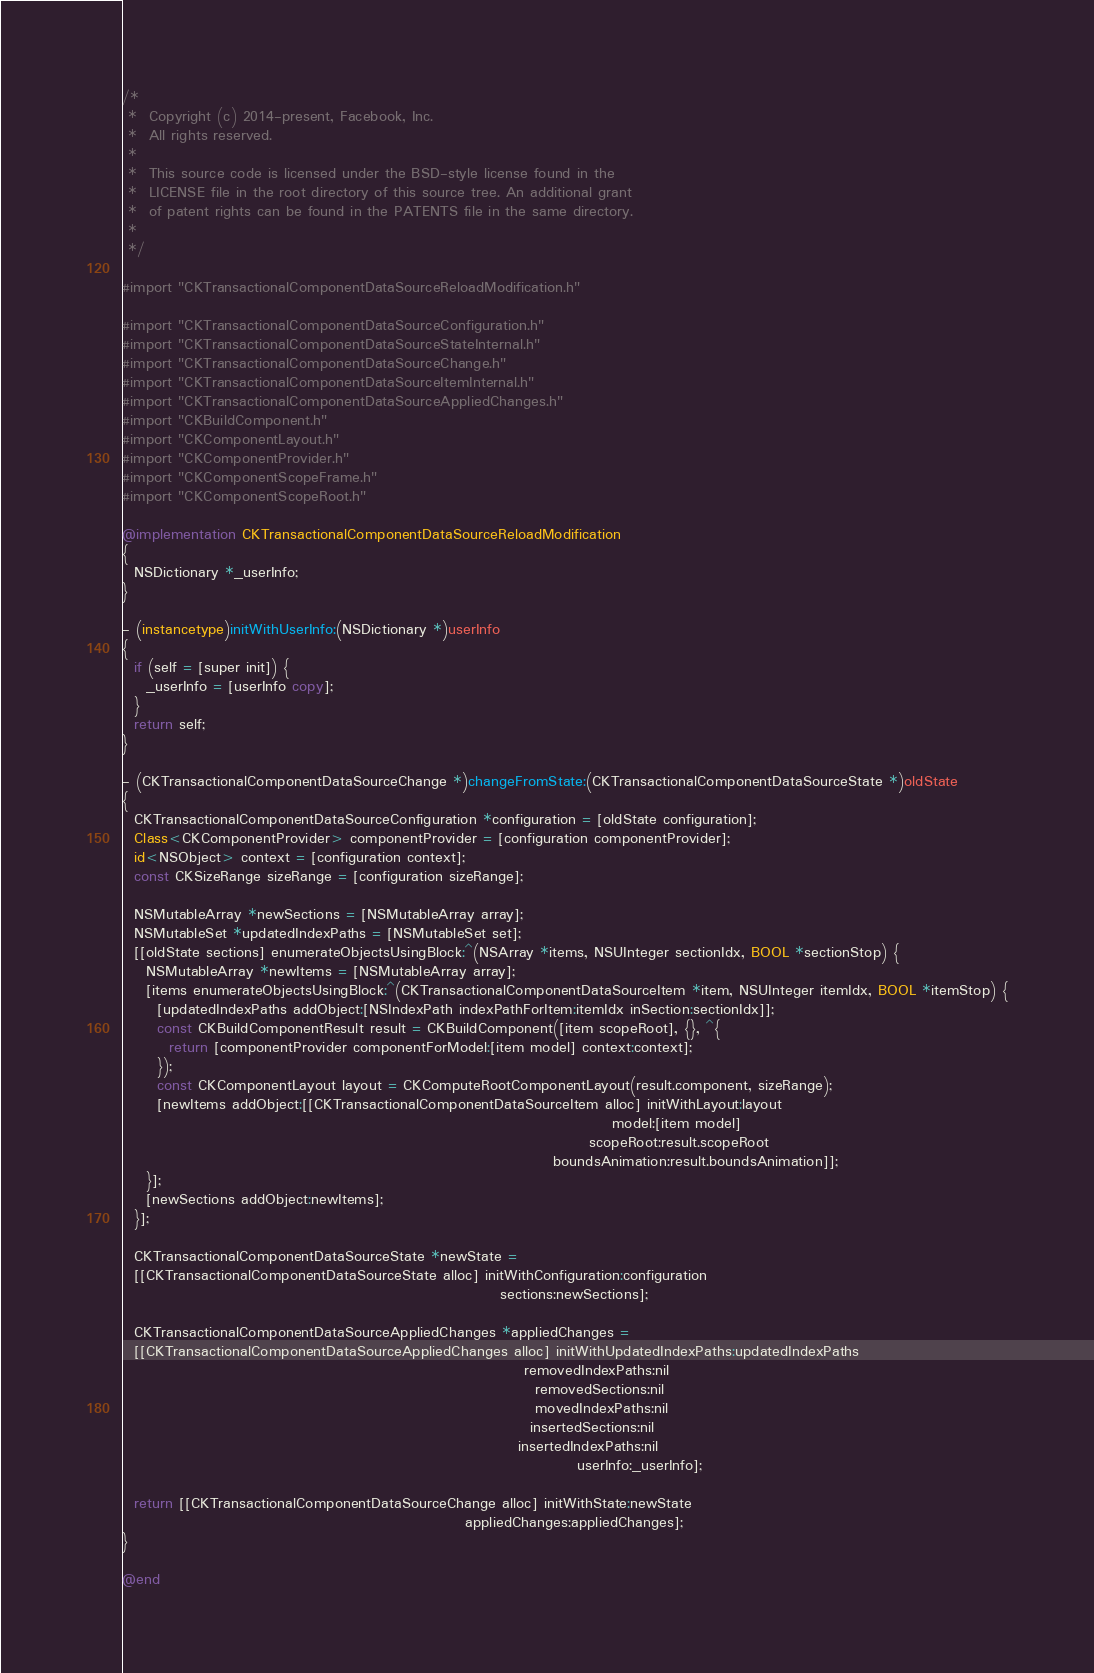<code> <loc_0><loc_0><loc_500><loc_500><_ObjectiveC_>/*
 *  Copyright (c) 2014-present, Facebook, Inc.
 *  All rights reserved.
 *
 *  This source code is licensed under the BSD-style license found in the
 *  LICENSE file in the root directory of this source tree. An additional grant
 *  of patent rights can be found in the PATENTS file in the same directory.
 *
 */

#import "CKTransactionalComponentDataSourceReloadModification.h"

#import "CKTransactionalComponentDataSourceConfiguration.h"
#import "CKTransactionalComponentDataSourceStateInternal.h"
#import "CKTransactionalComponentDataSourceChange.h"
#import "CKTransactionalComponentDataSourceItemInternal.h"
#import "CKTransactionalComponentDataSourceAppliedChanges.h"
#import "CKBuildComponent.h"
#import "CKComponentLayout.h"
#import "CKComponentProvider.h"
#import "CKComponentScopeFrame.h"
#import "CKComponentScopeRoot.h"

@implementation CKTransactionalComponentDataSourceReloadModification
{
  NSDictionary *_userInfo;
}

- (instancetype)initWithUserInfo:(NSDictionary *)userInfo
{
  if (self = [super init]) {
    _userInfo = [userInfo copy];
  }
  return self;
}

- (CKTransactionalComponentDataSourceChange *)changeFromState:(CKTransactionalComponentDataSourceState *)oldState
{
  CKTransactionalComponentDataSourceConfiguration *configuration = [oldState configuration];
  Class<CKComponentProvider> componentProvider = [configuration componentProvider];
  id<NSObject> context = [configuration context];
  const CKSizeRange sizeRange = [configuration sizeRange];

  NSMutableArray *newSections = [NSMutableArray array];
  NSMutableSet *updatedIndexPaths = [NSMutableSet set];
  [[oldState sections] enumerateObjectsUsingBlock:^(NSArray *items, NSUInteger sectionIdx, BOOL *sectionStop) {
    NSMutableArray *newItems = [NSMutableArray array];
    [items enumerateObjectsUsingBlock:^(CKTransactionalComponentDataSourceItem *item, NSUInteger itemIdx, BOOL *itemStop) {
      [updatedIndexPaths addObject:[NSIndexPath indexPathForItem:itemIdx inSection:sectionIdx]];
      const CKBuildComponentResult result = CKBuildComponent([item scopeRoot], {}, ^{
        return [componentProvider componentForModel:[item model] context:context];
      });
      const CKComponentLayout layout = CKComputeRootComponentLayout(result.component, sizeRange);
      [newItems addObject:[[CKTransactionalComponentDataSourceItem alloc] initWithLayout:layout
                                                                                   model:[item model]
                                                                               scopeRoot:result.scopeRoot
                                                                         boundsAnimation:result.boundsAnimation]];
    }];
    [newSections addObject:newItems];
  }];

  CKTransactionalComponentDataSourceState *newState =
  [[CKTransactionalComponentDataSourceState alloc] initWithConfiguration:configuration
                                                                sections:newSections];

  CKTransactionalComponentDataSourceAppliedChanges *appliedChanges =
  [[CKTransactionalComponentDataSourceAppliedChanges alloc] initWithUpdatedIndexPaths:updatedIndexPaths
                                                                    removedIndexPaths:nil
                                                                      removedSections:nil
                                                                      movedIndexPaths:nil
                                                                     insertedSections:nil
                                                                   insertedIndexPaths:nil
                                                                             userInfo:_userInfo];

  return [[CKTransactionalComponentDataSourceChange alloc] initWithState:newState
                                                          appliedChanges:appliedChanges];
}

@end
</code> 